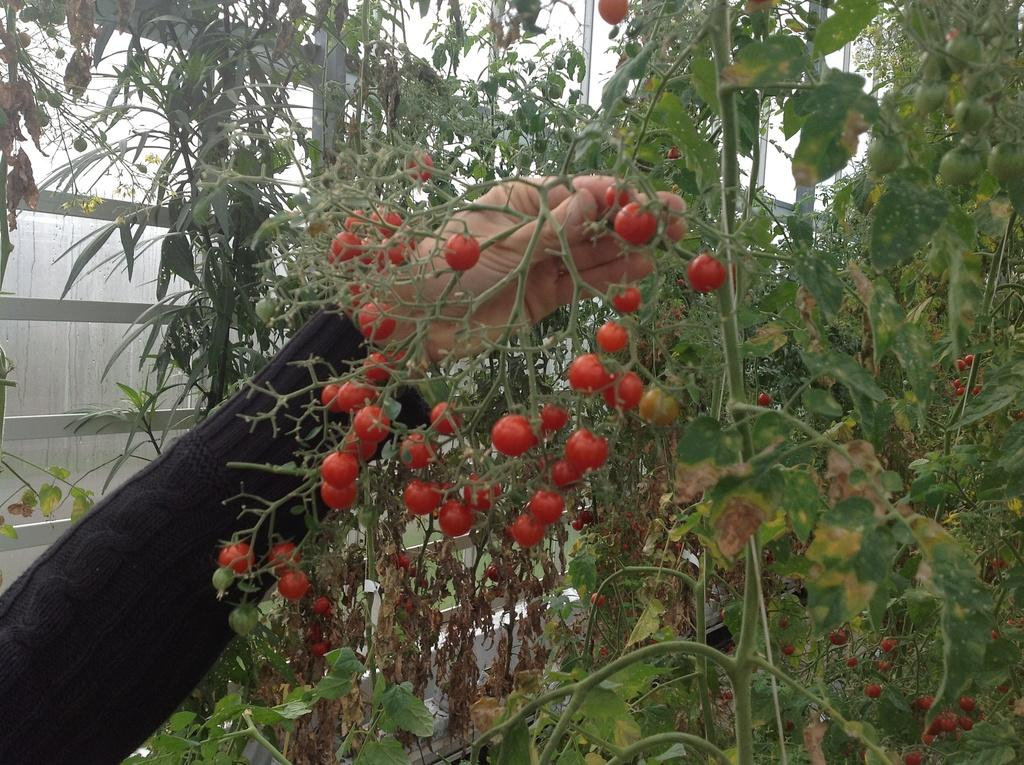What type of food can be seen in the image? There are tomatoes in the image. What else is present in the image besides tomatoes? There are plants, stems, leaves, and dry leaves in the image. Can you describe the person's interaction with the plant in the image? A person's hand is holding a plant stem in the image. What can be seen in the background of the image? There is a glass object in the background of the image. What type of crate is being used to store the tomatoes in the image? There is no crate present in the image; the tomatoes are not stored in a crate. Can you describe the police presence in the image? There is no police presence in the image; it does not feature any law enforcement personnel. 